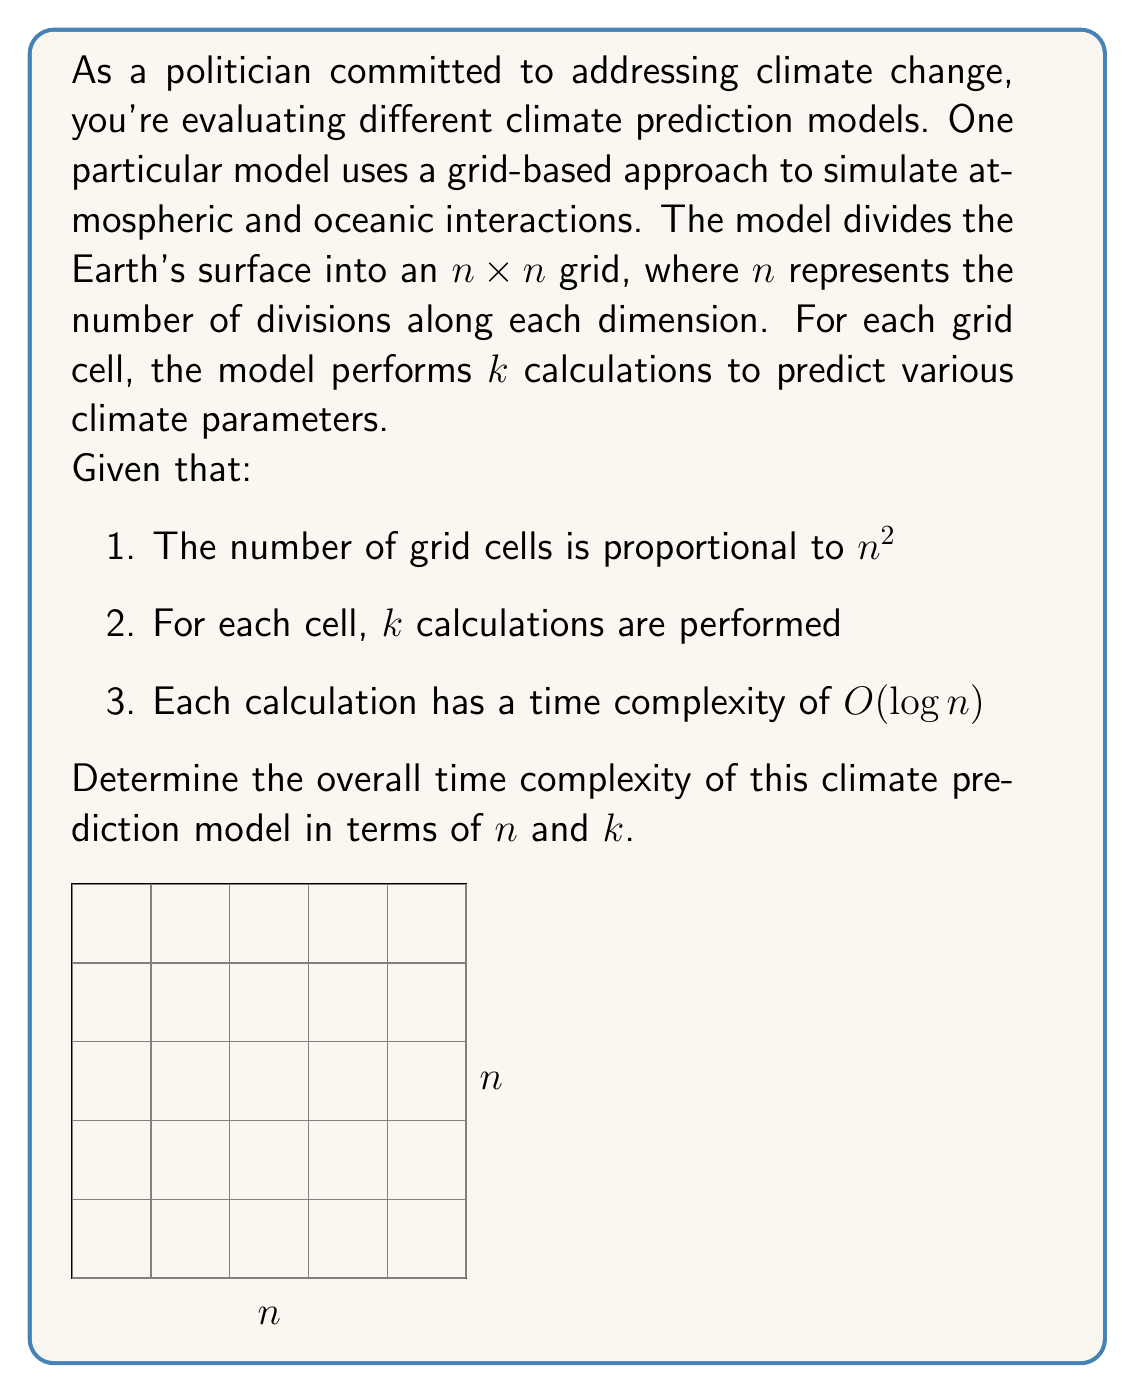Can you solve this math problem? To determine the overall time complexity, let's break down the problem step-by-step:

1) First, we need to calculate the total number of grid cells:
   - The grid is $n \times n$, so the number of cells is $n^2$

2) For each cell, we perform $k$ calculations:
   - Total number of calculations = $n^2 \cdot k$

3) Each calculation has a time complexity of $O(\log n)$:
   - Time for one calculation = $O(\log n)$

4) To get the total time complexity, we multiply the number of calculations by the time for each calculation:
   $$O(n^2 \cdot k \cdot \log n)$$

5) Simplifying the expression:
   $$O(kn^2 \log n)$$

This represents the overall time complexity of the climate prediction model. It's important to note that:
- The complexity grows quadratically with $n$ (due to $n^2$)
- It grows linearly with $k$
- There's an additional logarithmic factor ($\log n$)

For a politician, this means that as we increase the resolution of our grid (increasing $n$) or the number of calculations per cell (increasing $k$), the computational time will increase significantly. This has implications for the feasibility and cost of running high-resolution, complex climate models.
Answer: $O(kn^2 \log n)$ 